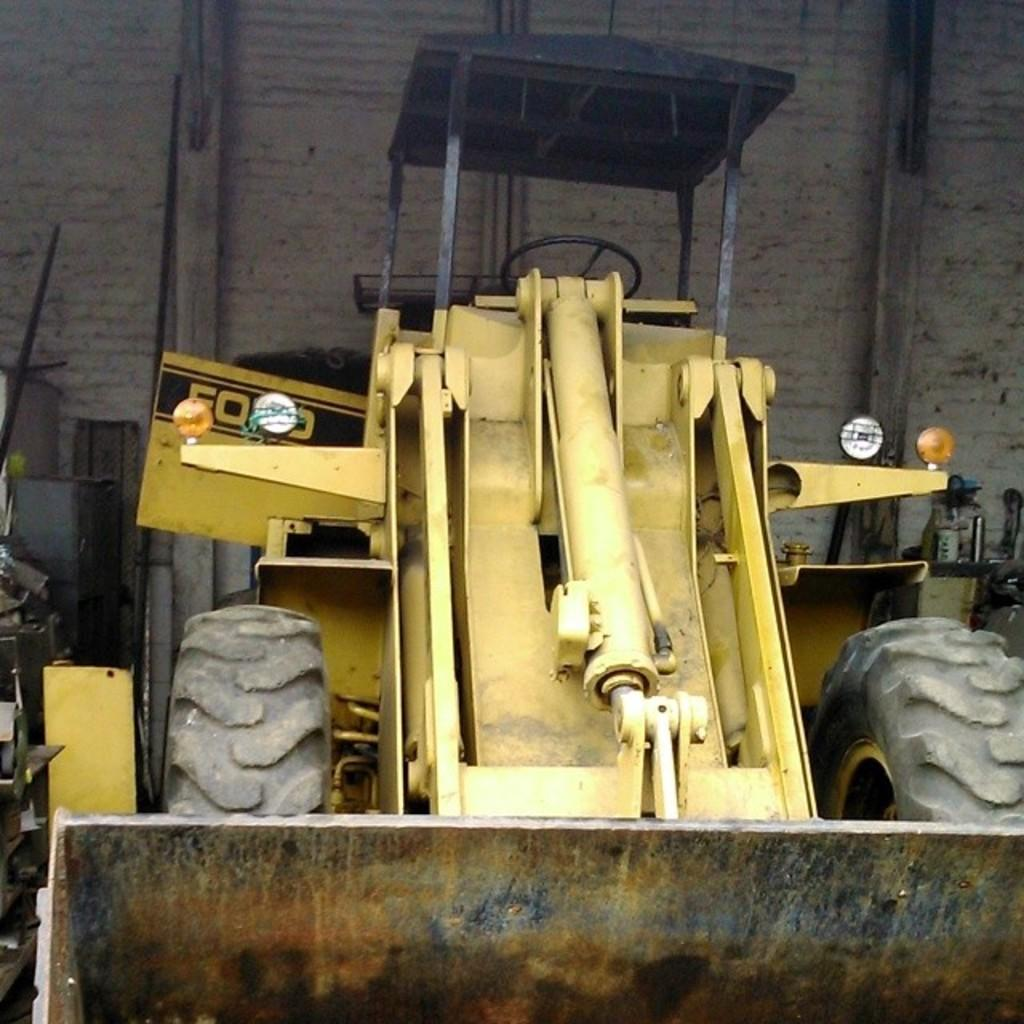What type of vehicle is on the ground in the image? There is a bulldozer on the ground in the image. What can be seen in the background of the image? There is a wall visible in the background of the image. What else is on the ground near the bulldozer? There are a few objects on the ground to the left of the bulldozer. How much tax is being paid for the bucket on the ground in the image? There is no bucket present in the image, and therefore no tax can be associated with it. 